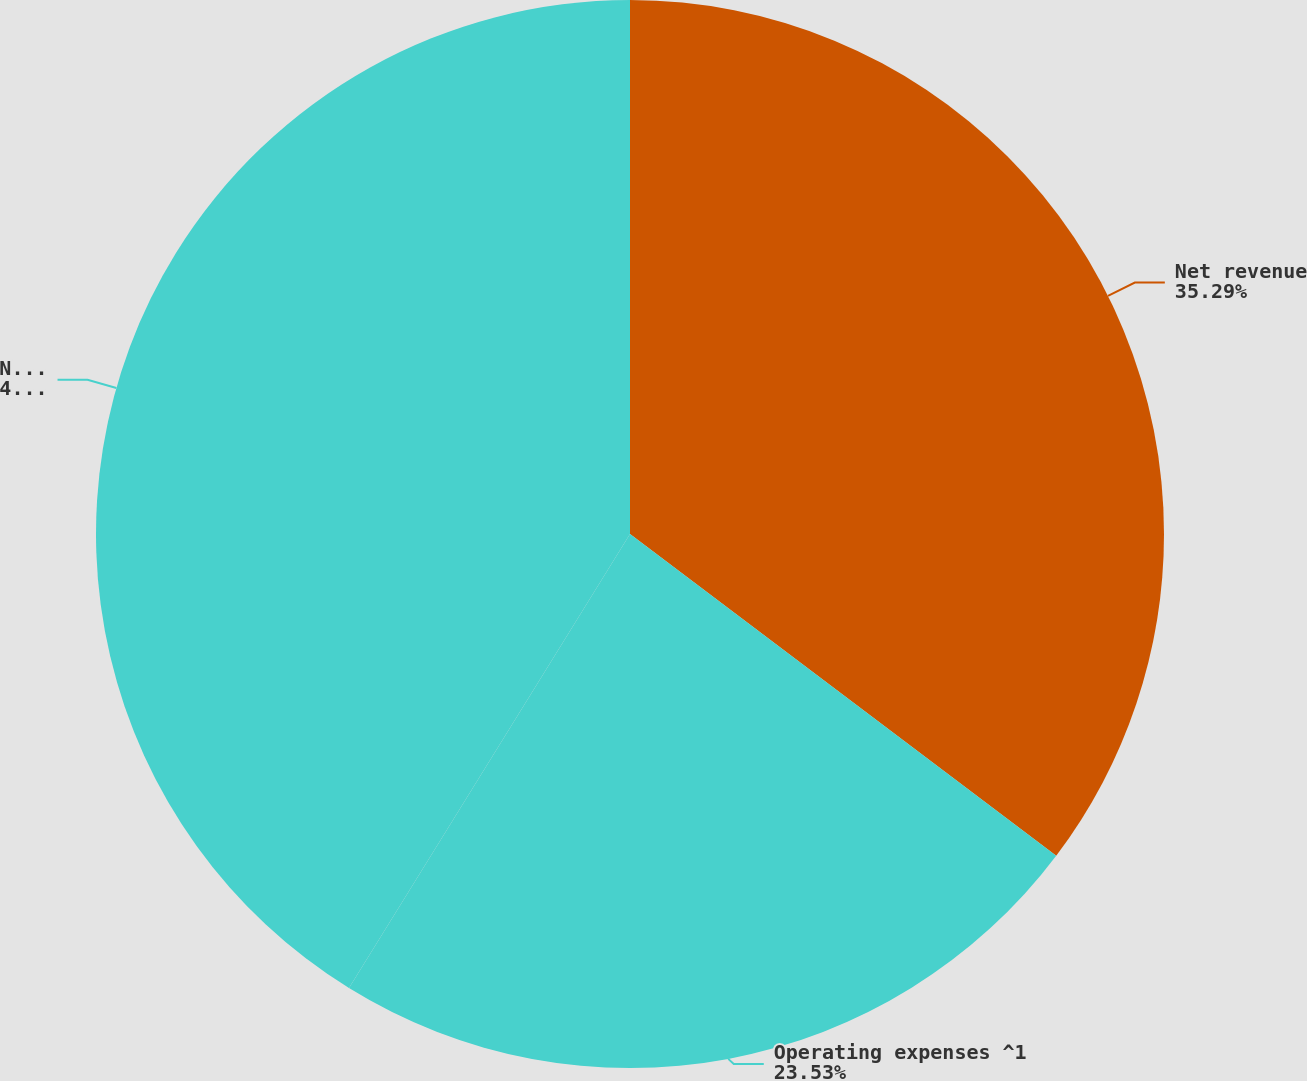<chart> <loc_0><loc_0><loc_500><loc_500><pie_chart><fcel>Net revenue<fcel>Operating expenses ^1<fcel>Net income ^1<nl><fcel>35.29%<fcel>23.53%<fcel>41.18%<nl></chart> 